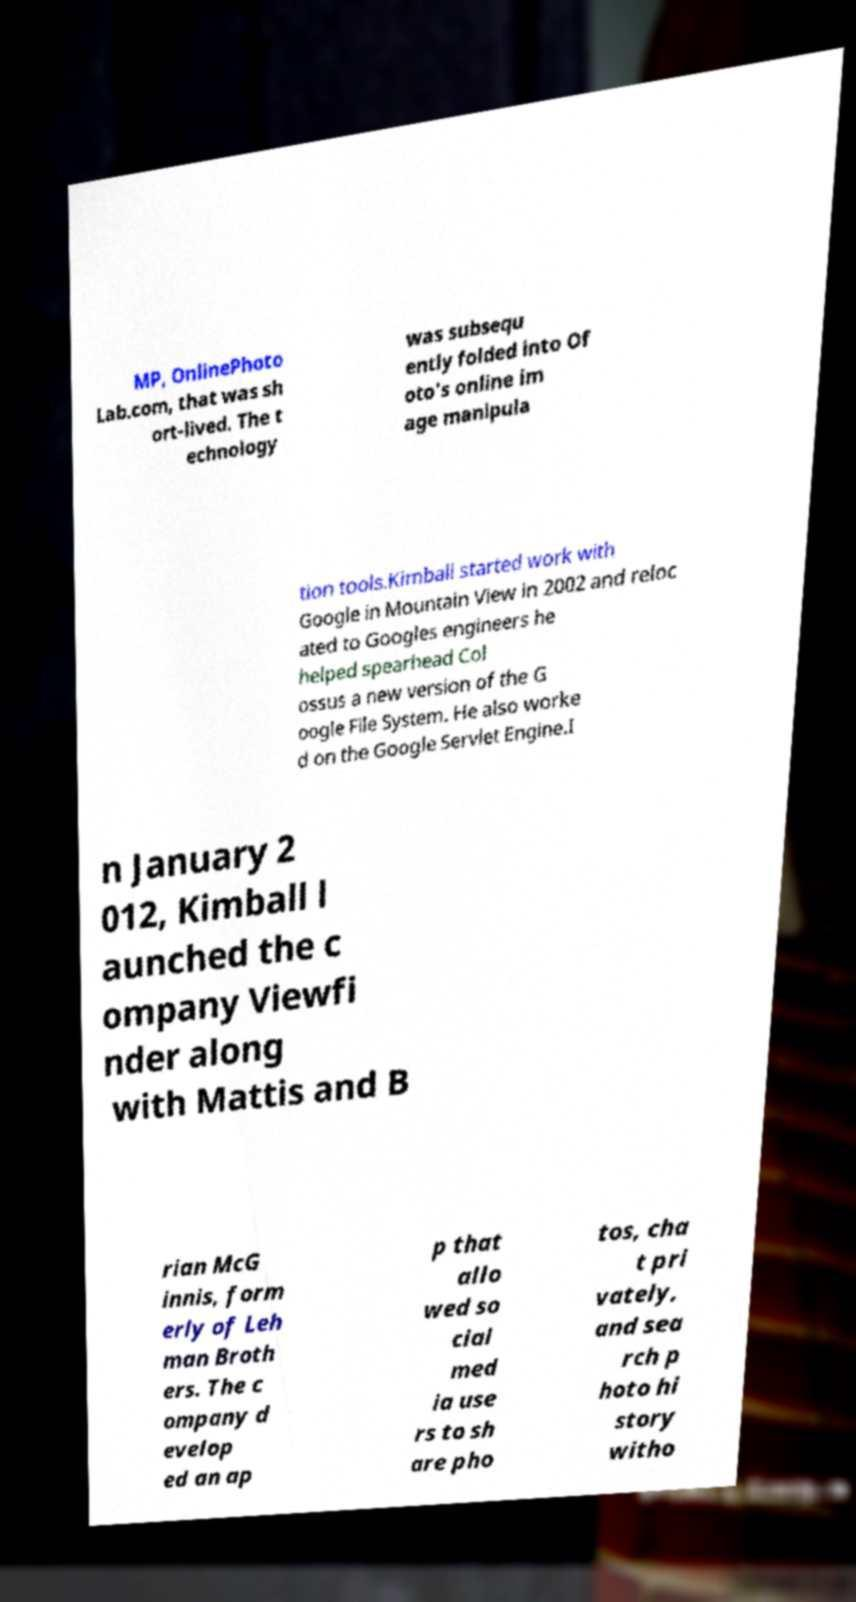There's text embedded in this image that I need extracted. Can you transcribe it verbatim? MP, OnlinePhoto Lab.com, that was sh ort-lived. The t echnology was subsequ ently folded into Of oto's online im age manipula tion tools.Kimball started work with Google in Mountain View in 2002 and reloc ated to Googles engineers he helped spearhead Col ossus a new version of the G oogle File System. He also worke d on the Google Servlet Engine.I n January 2 012, Kimball l aunched the c ompany Viewfi nder along with Mattis and B rian McG innis, form erly of Leh man Broth ers. The c ompany d evelop ed an ap p that allo wed so cial med ia use rs to sh are pho tos, cha t pri vately, and sea rch p hoto hi story witho 